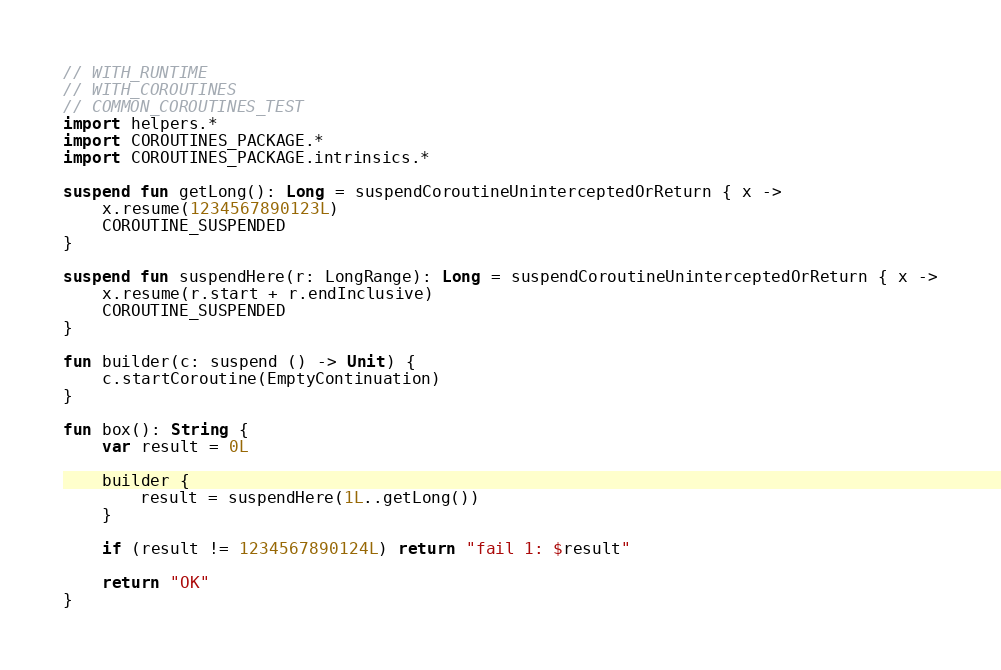<code> <loc_0><loc_0><loc_500><loc_500><_Kotlin_>// WITH_RUNTIME
// WITH_COROUTINES
// COMMON_COROUTINES_TEST
import helpers.*
import COROUTINES_PACKAGE.*
import COROUTINES_PACKAGE.intrinsics.*

suspend fun getLong(): Long = suspendCoroutineUninterceptedOrReturn { x ->
    x.resume(1234567890123L)
    COROUTINE_SUSPENDED
}

suspend fun suspendHere(r: LongRange): Long = suspendCoroutineUninterceptedOrReturn { x ->
    x.resume(r.start + r.endInclusive)
    COROUTINE_SUSPENDED
}

fun builder(c: suspend () -> Unit) {
    c.startCoroutine(EmptyContinuation)
}

fun box(): String {
    var result = 0L

    builder {
        result = suspendHere(1L..getLong())
    }

    if (result != 1234567890124L) return "fail 1: $result"

    return "OK"
}
</code> 